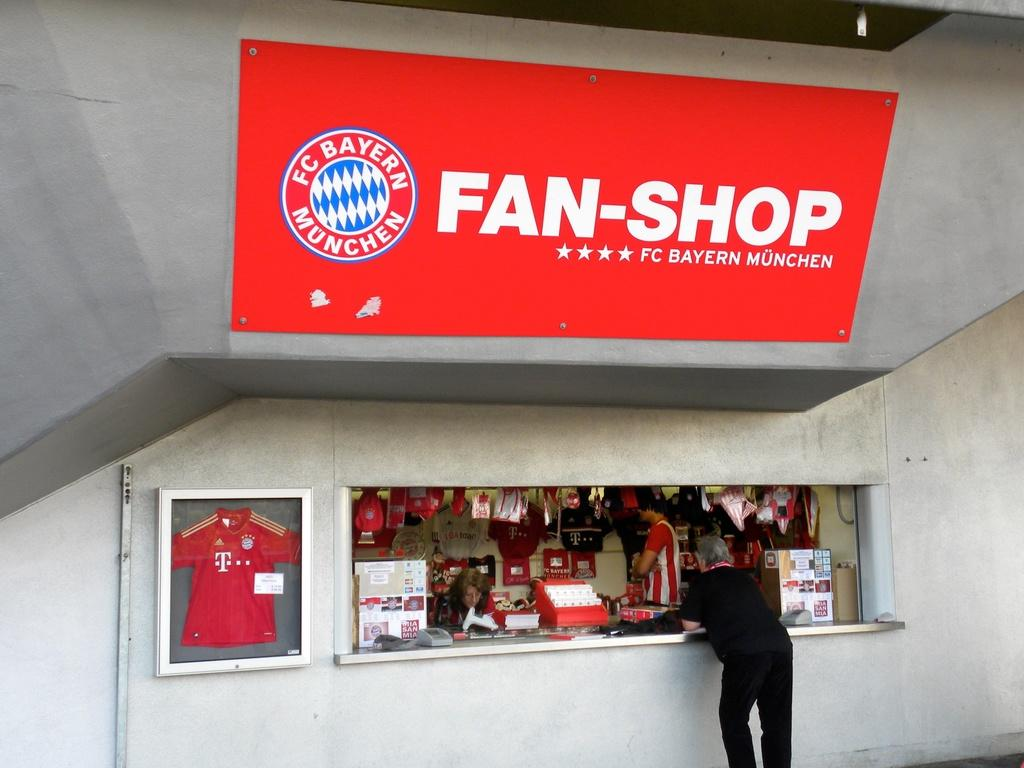<image>
Relay a brief, clear account of the picture shown. A man stands at a counter with a Fan-Shop sign above him. 